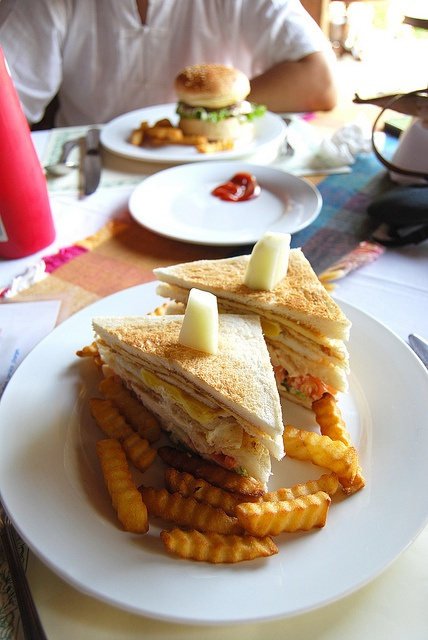Describe the objects in this image and their specific colors. I can see dining table in lightgray, olive, maroon, darkgray, and brown tones, people in olive, darkgray, gray, and white tones, sandwich in olive, ivory, and maroon tones, sandwich in olive, khaki, beige, and tan tones, and bottle in olive, brown, red, and salmon tones in this image. 